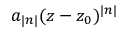Convert formula to latex. <formula><loc_0><loc_0><loc_500><loc_500>a _ { | n | } ( z - z _ { 0 } ) ^ { | n | }</formula> 